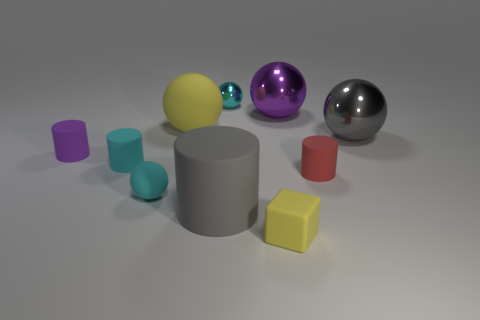Subtract all gray spheres. How many spheres are left? 4 Subtract all large purple spheres. How many spheres are left? 4 Subtract all red balls. Subtract all red cubes. How many balls are left? 5 Subtract all cubes. How many objects are left? 9 Subtract 0 brown balls. How many objects are left? 10 Subtract all small yellow rubber blocks. Subtract all small objects. How many objects are left? 3 Add 8 large gray matte cylinders. How many large gray matte cylinders are left? 9 Add 6 large blue cubes. How many large blue cubes exist? 6 